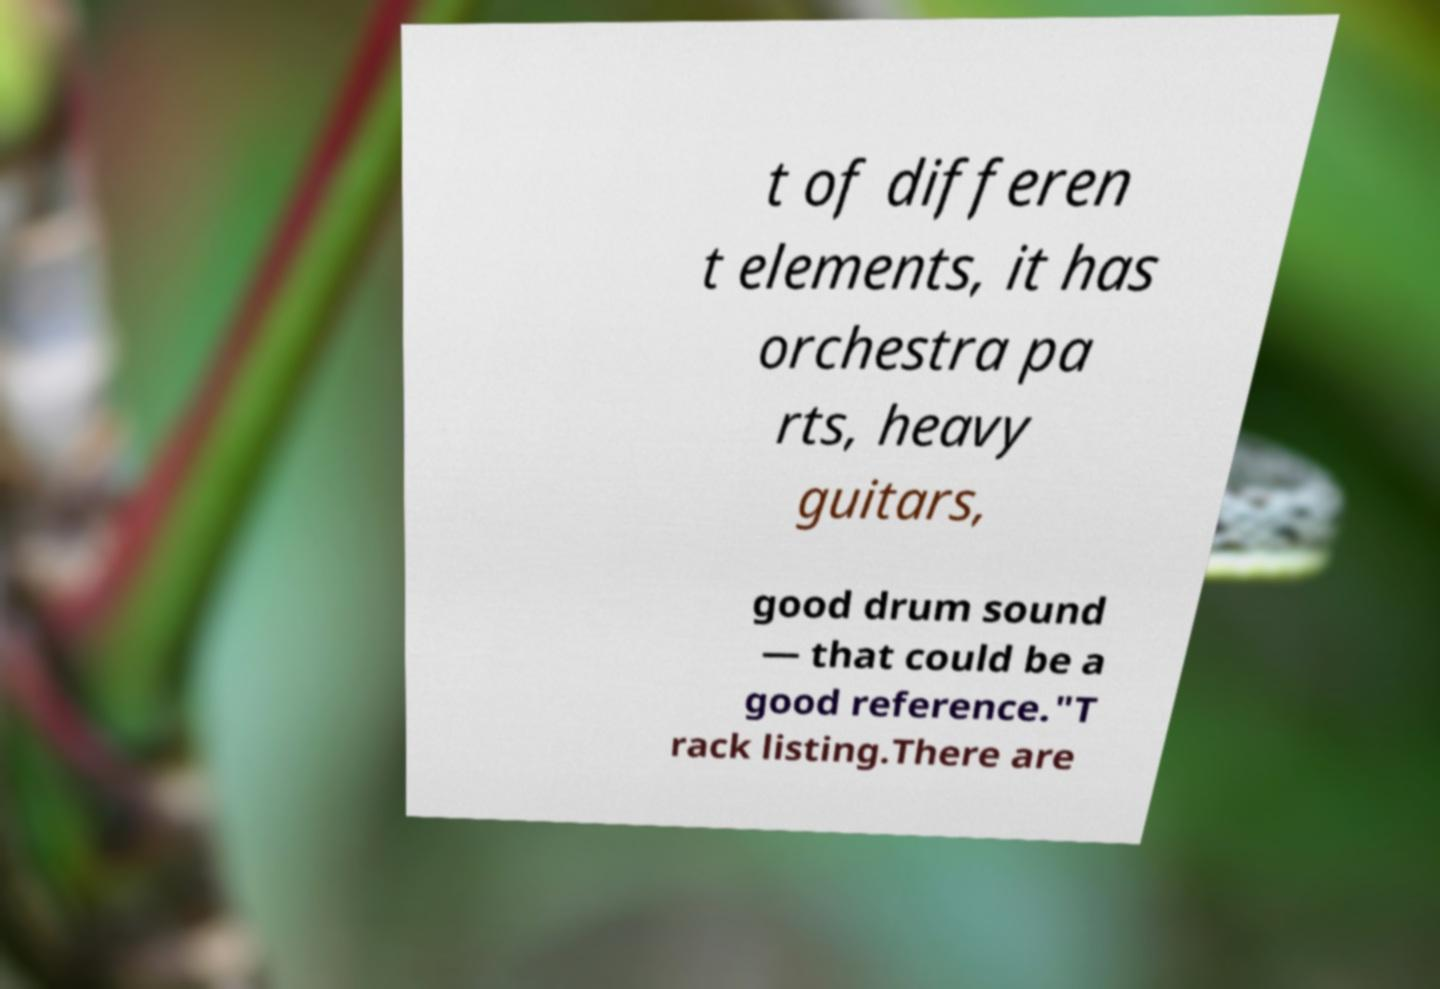For documentation purposes, I need the text within this image transcribed. Could you provide that? t of differen t elements, it has orchestra pa rts, heavy guitars, good drum sound — that could be a good reference."T rack listing.There are 